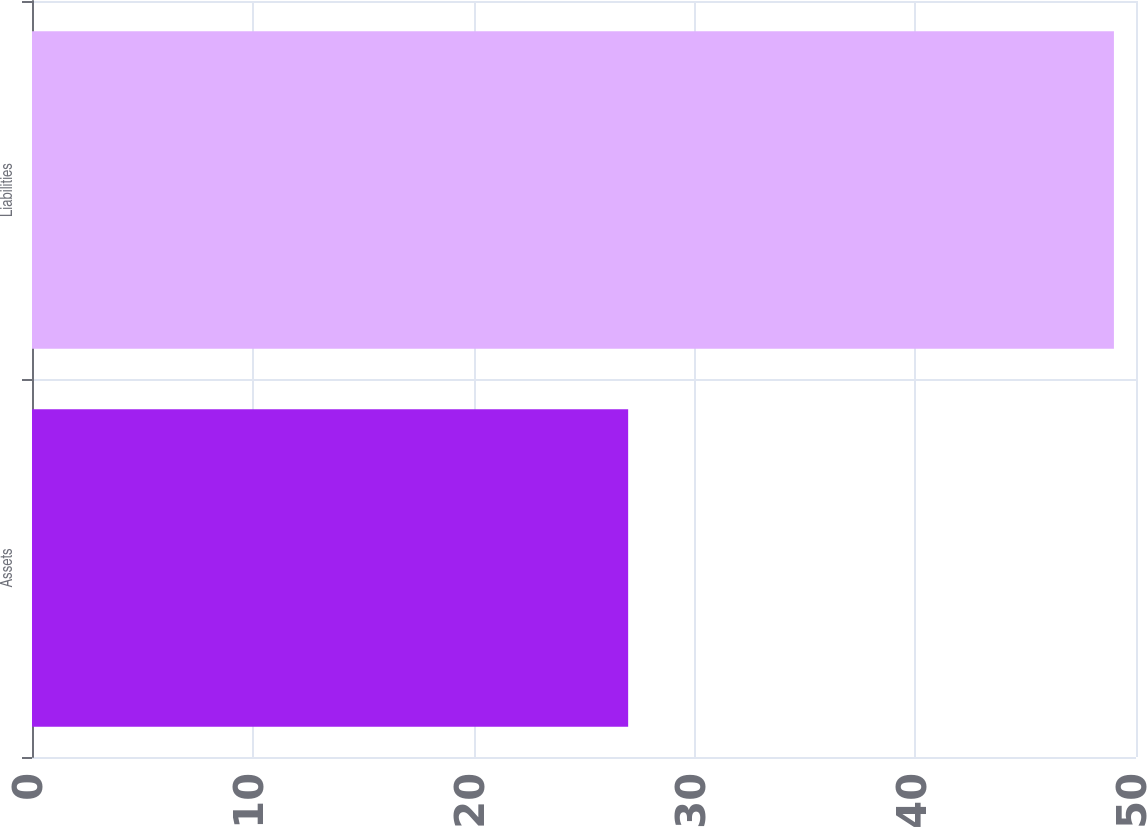Convert chart to OTSL. <chart><loc_0><loc_0><loc_500><loc_500><bar_chart><fcel>Assets<fcel>Liabilities<nl><fcel>27<fcel>49<nl></chart> 